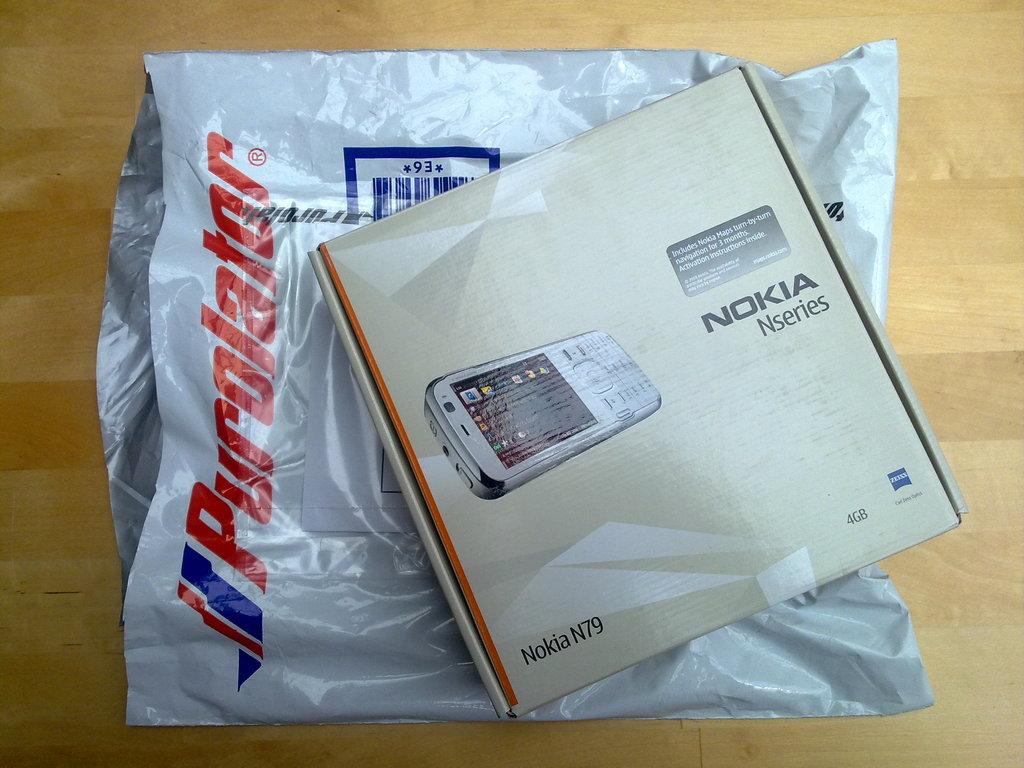What series on nokia is shown?
Your answer should be very brief. N series. There are nokia phone?
Keep it short and to the point. Yes. 